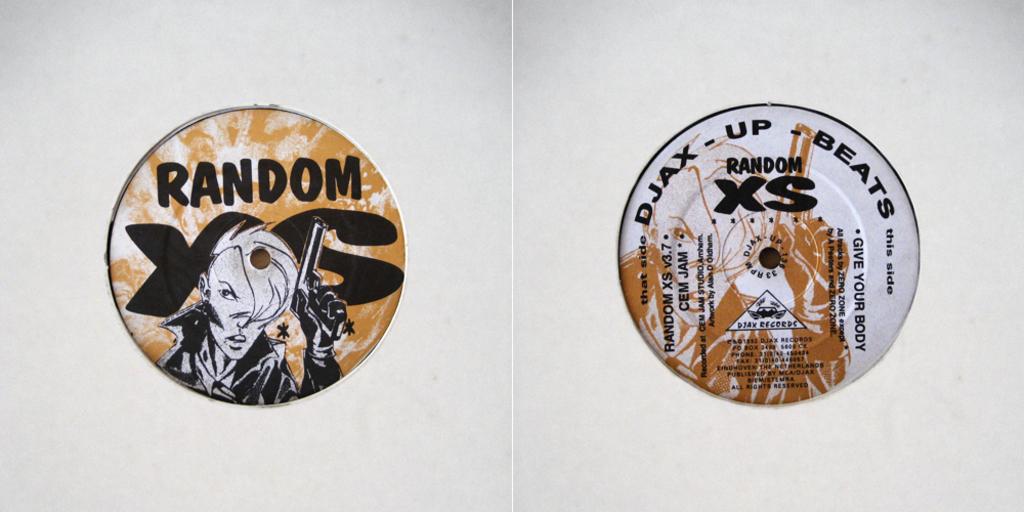What does the right side vinyl say?
Give a very brief answer. Random xs. 